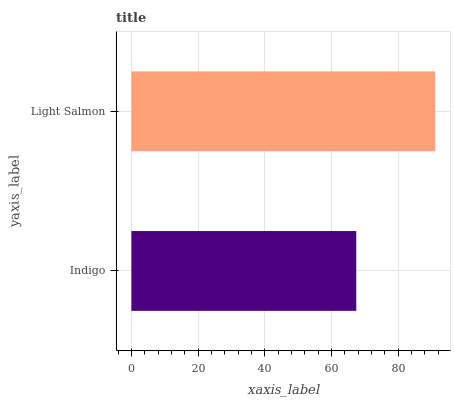Is Indigo the minimum?
Answer yes or no. Yes. Is Light Salmon the maximum?
Answer yes or no. Yes. Is Light Salmon the minimum?
Answer yes or no. No. Is Light Salmon greater than Indigo?
Answer yes or no. Yes. Is Indigo less than Light Salmon?
Answer yes or no. Yes. Is Indigo greater than Light Salmon?
Answer yes or no. No. Is Light Salmon less than Indigo?
Answer yes or no. No. Is Light Salmon the high median?
Answer yes or no. Yes. Is Indigo the low median?
Answer yes or no. Yes. Is Indigo the high median?
Answer yes or no. No. Is Light Salmon the low median?
Answer yes or no. No. 